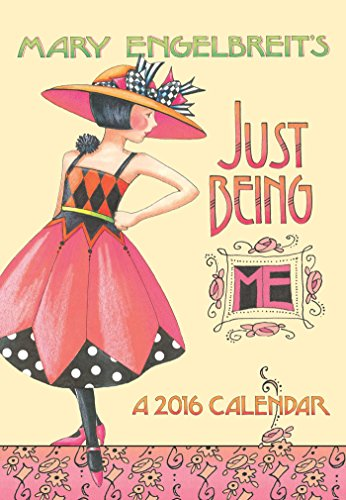What type of book is this? This is a pocket-sized planner for the year 2016, categorized under calendars. It serves as a handy tool for organizing dates and events throughout the year, embellished with artistic illustrations. 